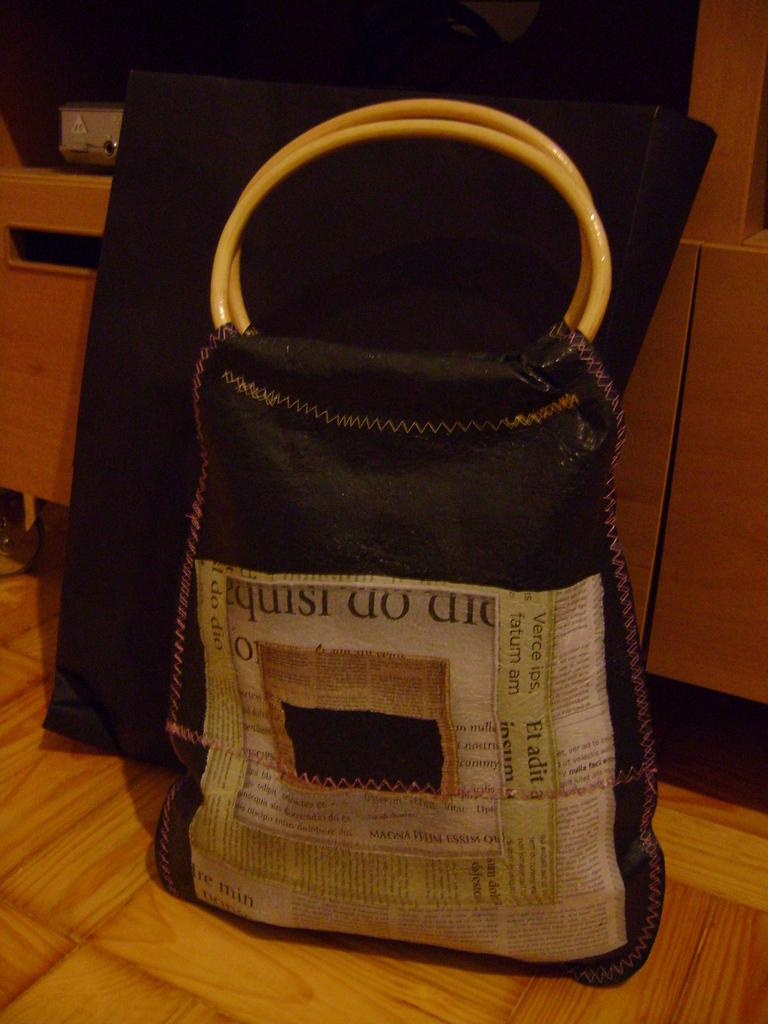What object is on the table in the image? There is a carry bag on the table in the image. What can be seen in the background of the image? There are cupboards in the background of the image. What grade does the farmer give to the kiss in the image? There is no farmer, grade, or kiss present in the image. 